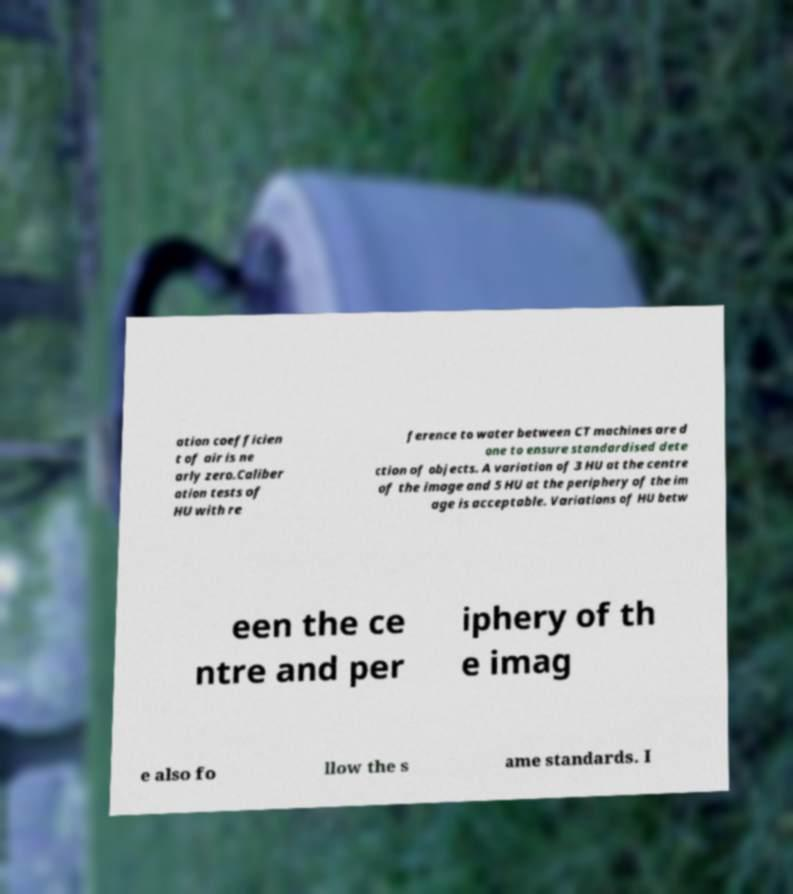What messages or text are displayed in this image? I need them in a readable, typed format. ation coefficien t of air is ne arly zero.Caliber ation tests of HU with re ference to water between CT machines are d one to ensure standardised dete ction of objects. A variation of 3 HU at the centre of the image and 5 HU at the periphery of the im age is acceptable. Variations of HU betw een the ce ntre and per iphery of th e imag e also fo llow the s ame standards. I 